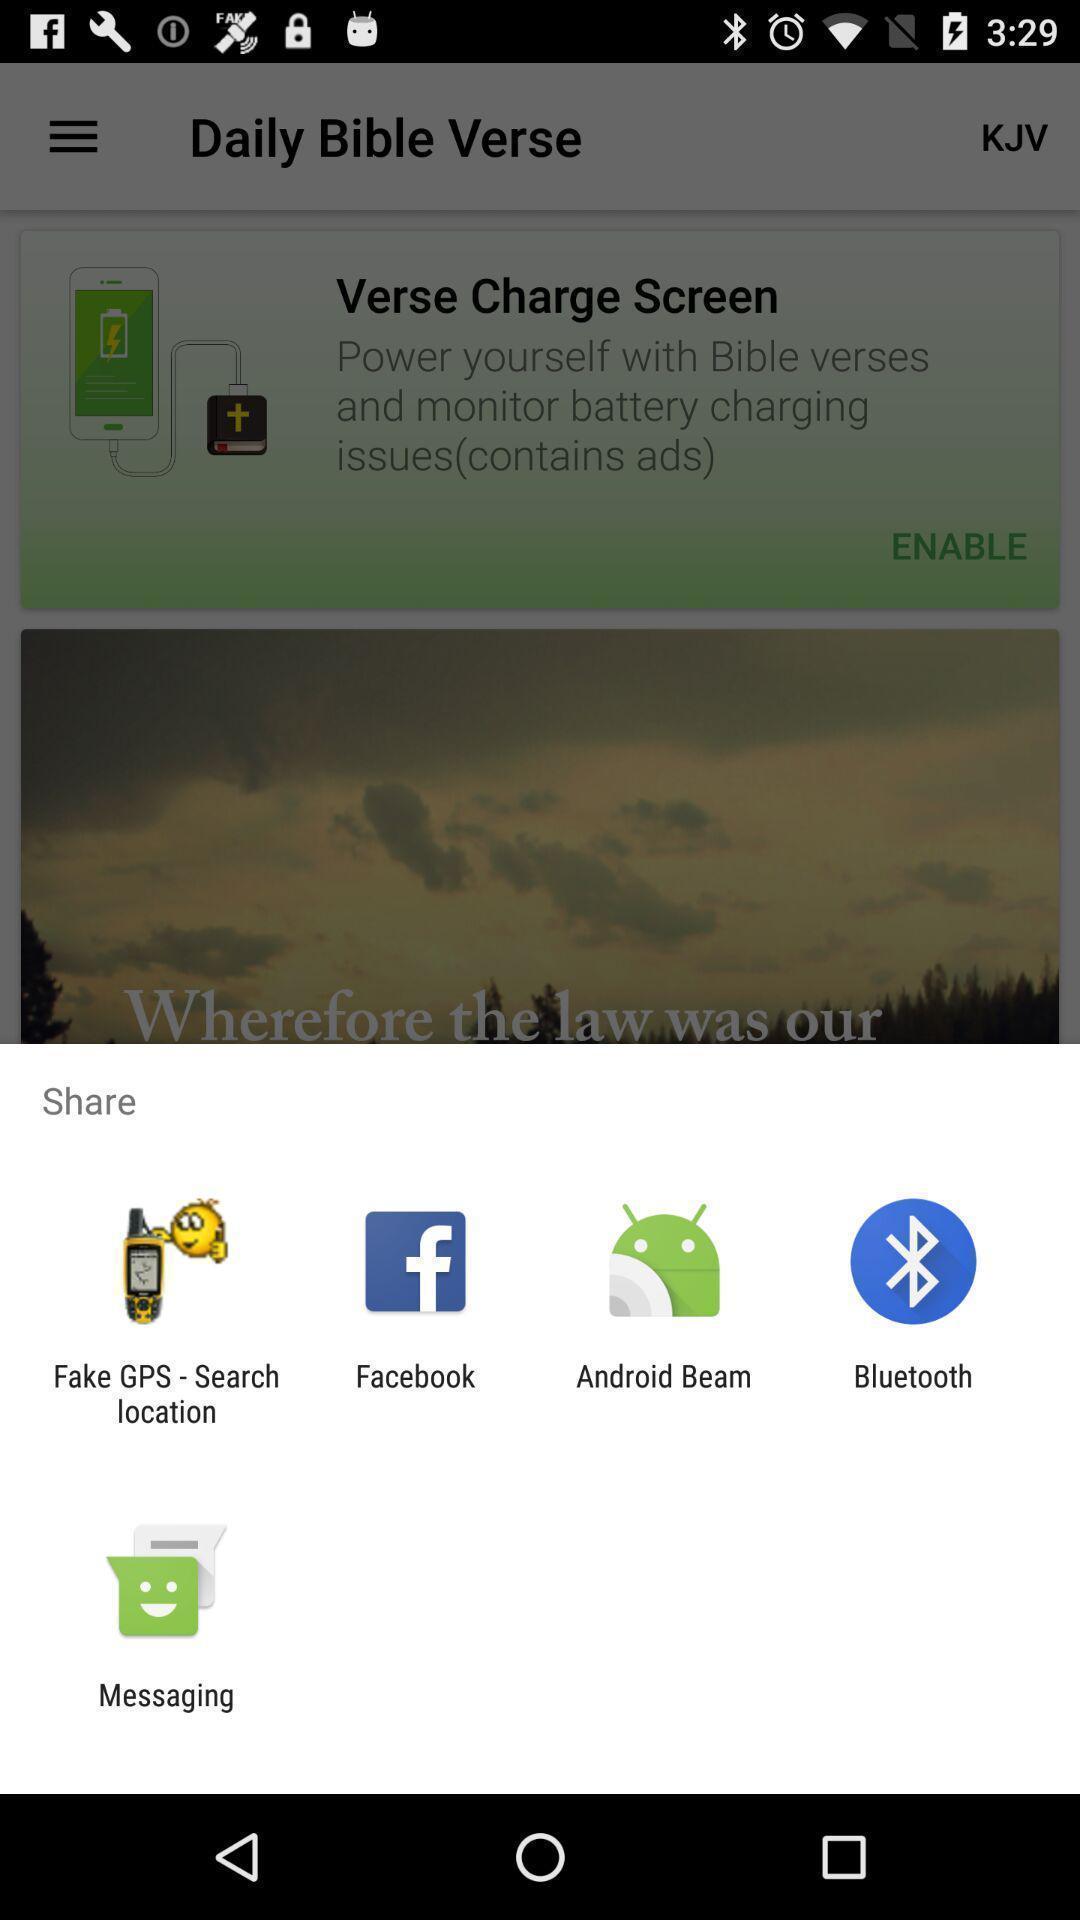What details can you identify in this image? Sharing options in a mobile. 